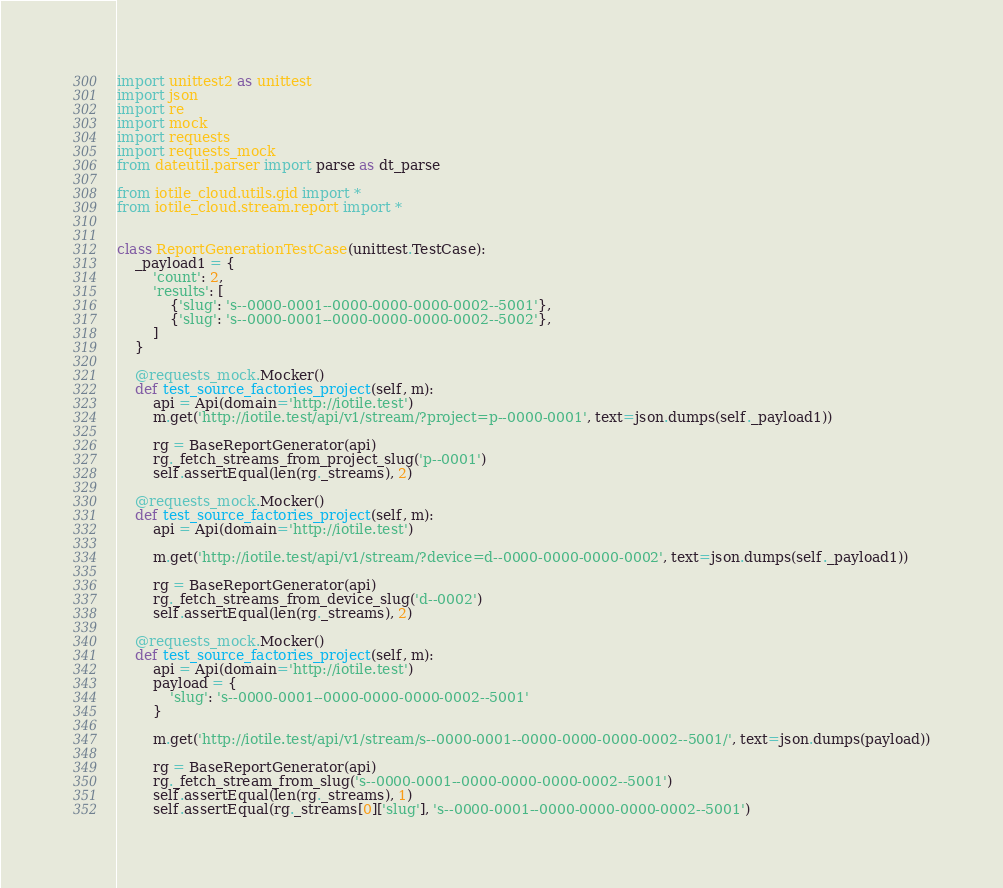Convert code to text. <code><loc_0><loc_0><loc_500><loc_500><_Python_>import unittest2 as unittest
import json
import re
import mock
import requests
import requests_mock
from dateutil.parser import parse as dt_parse

from iotile_cloud.utils.gid import *
from iotile_cloud.stream.report import *


class ReportGenerationTestCase(unittest.TestCase):
    _payload1 = {
        'count': 2,
        'results': [
            {'slug': 's--0000-0001--0000-0000-0000-0002--5001'},
            {'slug': 's--0000-0001--0000-0000-0000-0002--5002'},
        ]
    }

    @requests_mock.Mocker()
    def test_source_factories_project(self, m):
        api = Api(domain='http://iotile.test')
        m.get('http://iotile.test/api/v1/stream/?project=p--0000-0001', text=json.dumps(self._payload1))

        rg = BaseReportGenerator(api)
        rg._fetch_streams_from_project_slug('p--0001')
        self.assertEqual(len(rg._streams), 2)

    @requests_mock.Mocker()
    def test_source_factories_project(self, m):
        api = Api(domain='http://iotile.test')

        m.get('http://iotile.test/api/v1/stream/?device=d--0000-0000-0000-0002', text=json.dumps(self._payload1))

        rg = BaseReportGenerator(api)
        rg._fetch_streams_from_device_slug('d--0002')
        self.assertEqual(len(rg._streams), 2)

    @requests_mock.Mocker()
    def test_source_factories_project(self, m):
        api = Api(domain='http://iotile.test')
        payload = {
            'slug': 's--0000-0001--0000-0000-0000-0002--5001'
        }

        m.get('http://iotile.test/api/v1/stream/s--0000-0001--0000-0000-0000-0002--5001/', text=json.dumps(payload))

        rg = BaseReportGenerator(api)
        rg._fetch_stream_from_slug('s--0000-0001--0000-0000-0000-0002--5001')
        self.assertEqual(len(rg._streams), 1)
        self.assertEqual(rg._streams[0]['slug'], 's--0000-0001--0000-0000-0000-0002--5001')
</code> 